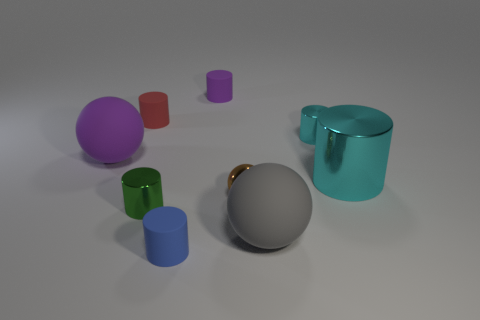Subtract all green cylinders. How many cylinders are left? 5 Subtract all tiny red rubber cylinders. How many cylinders are left? 5 Subtract all yellow cylinders. Subtract all yellow cubes. How many cylinders are left? 6 Subtract all spheres. How many objects are left? 6 Subtract all small red cylinders. Subtract all big purple balls. How many objects are left? 7 Add 7 tiny green metallic cylinders. How many tiny green metallic cylinders are left? 8 Add 6 tiny brown spheres. How many tiny brown spheres exist? 7 Subtract 0 cyan balls. How many objects are left? 9 